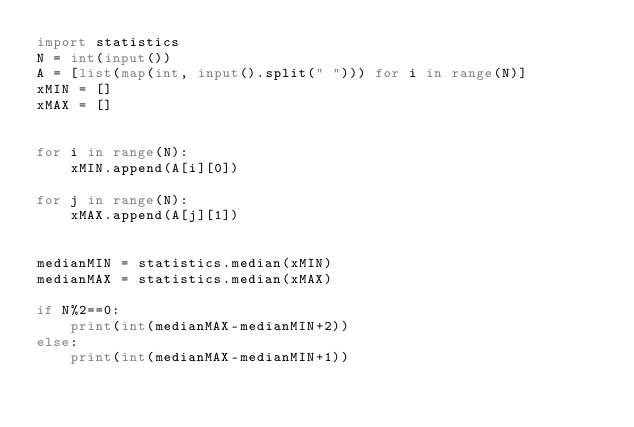Convert code to text. <code><loc_0><loc_0><loc_500><loc_500><_Python_>import statistics
N = int(input())
A = [list(map(int, input().split(" "))) for i in range(N)]
xMIN = []
xMAX = []


for i in range(N):
    xMIN.append(A[i][0])

for j in range(N):
    xMAX.append(A[j][1])


medianMIN = statistics.median(xMIN)
medianMAX = statistics.median(xMAX)

if N%2==0:
    print(int(medianMAX-medianMIN+2))
else:
    print(int(medianMAX-medianMIN+1))
</code> 